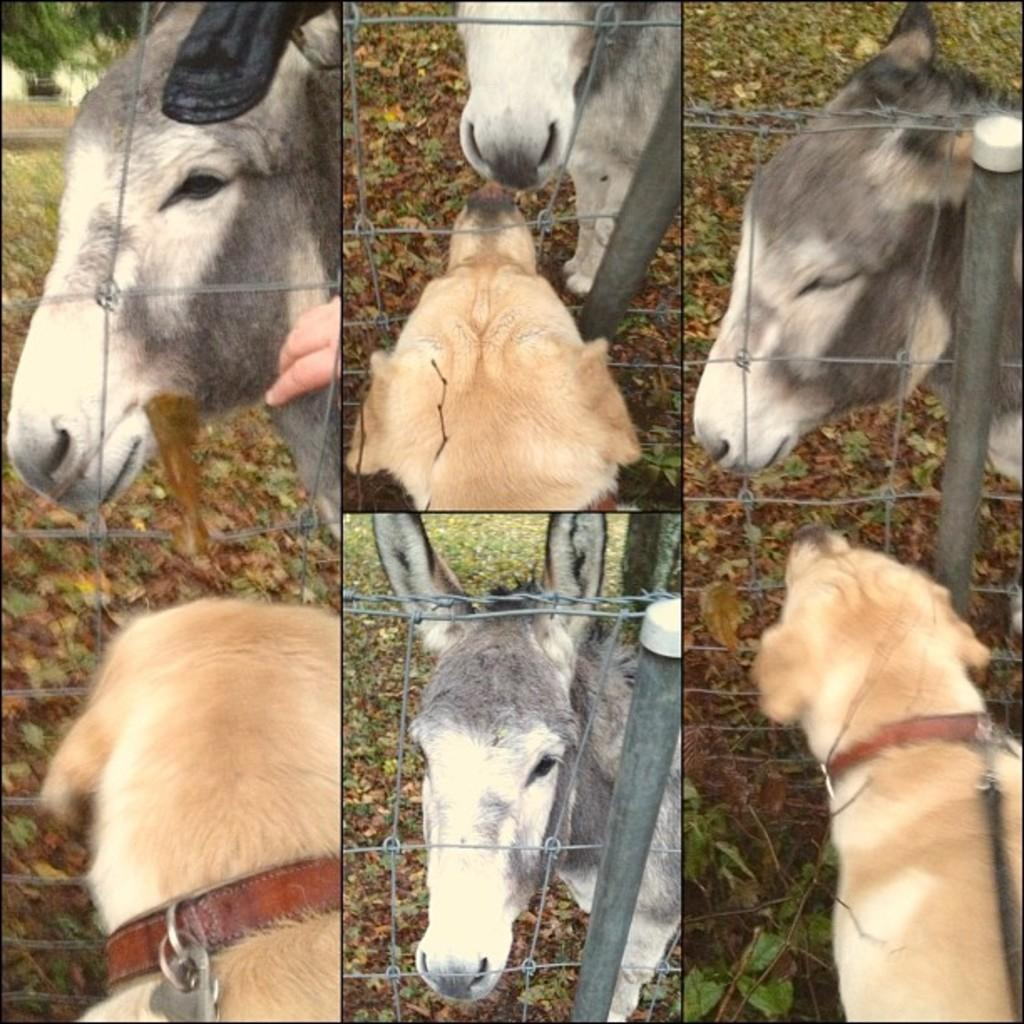How many dogs are at the bottom of the image? There are two dogs at the bottom of the image. How many donkeys are at the bottom of the image? There is one donkey at the bottom of the image. How many donkeys are at the top of the image? There are three donkeys at the top of the image. How many dogs are at the top of the image? There is one dog at the top of the image. What type of vegetation is visible in the image? There is grass visible in the image. What object is present in the image that might be used for catching or holding? There is a net present in the image. What type of farm can be seen in the image? There is no farm present in the image; it features animals and a net. What type of needle is being used by the dog at the top of the image? There is no needle present in the image; it features animals and a net. 